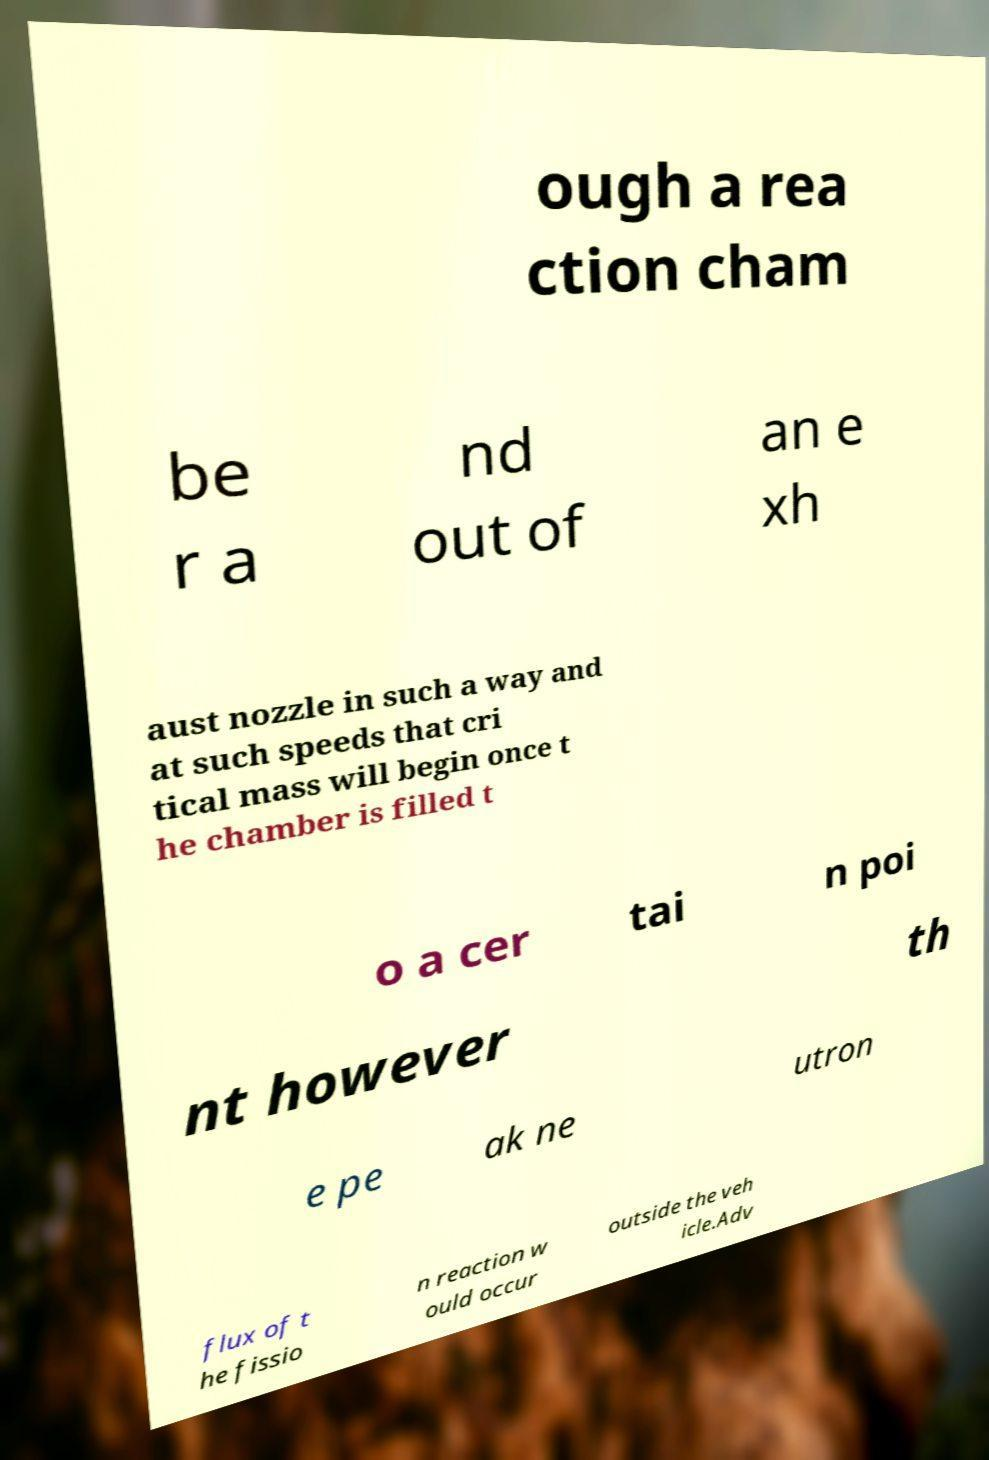Please read and relay the text visible in this image. What does it say? ough a rea ction cham be r a nd out of an e xh aust nozzle in such a way and at such speeds that cri tical mass will begin once t he chamber is filled t o a cer tai n poi nt however th e pe ak ne utron flux of t he fissio n reaction w ould occur outside the veh icle.Adv 